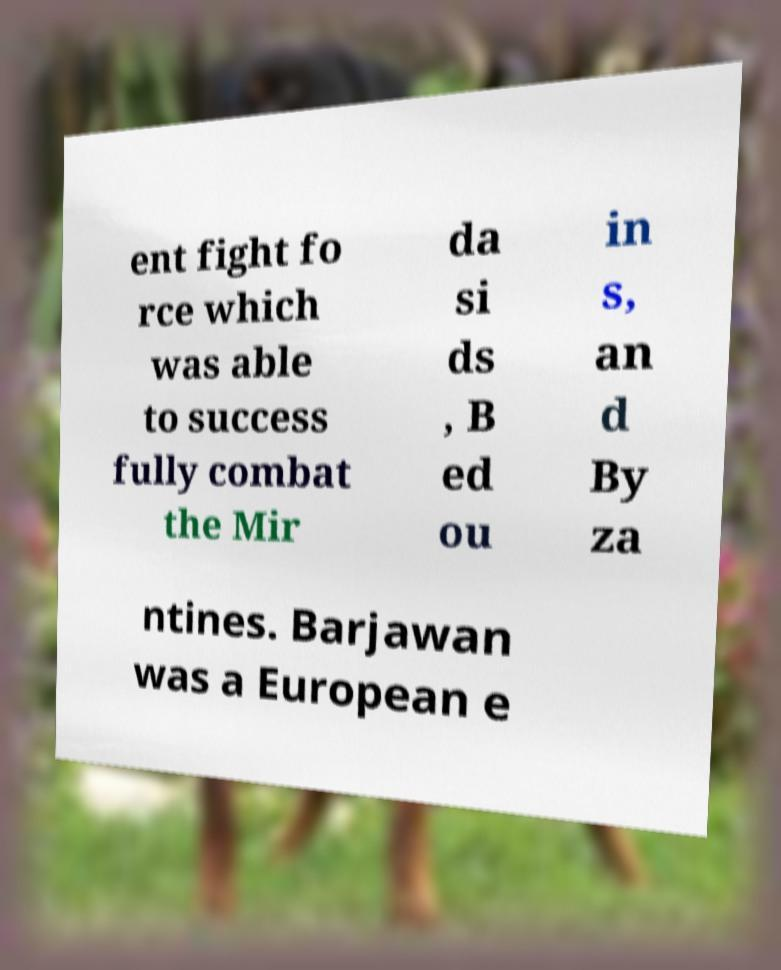Please identify and transcribe the text found in this image. ent fight fo rce which was able to success fully combat the Mir da si ds , B ed ou in s, an d By za ntines. Barjawan was a European e 